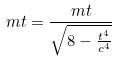<formula> <loc_0><loc_0><loc_500><loc_500>m t = \frac { m t } { \sqrt { 8 - \frac { t ^ { 4 } } { c ^ { 4 } } } }</formula> 